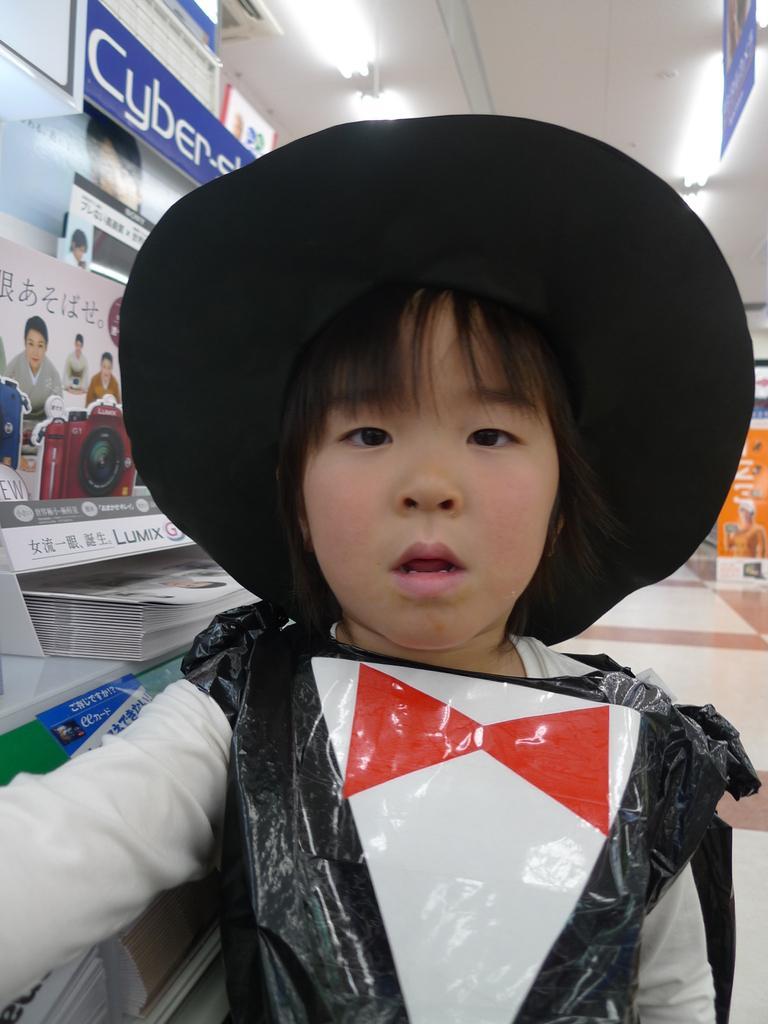In one or two sentences, can you explain what this image depicts? In this image we can see a child wearing a hat. On the ceiling there are lights. On the left side we can see banners. On that there is a camera, images of people and also something is written. And there is a rack with papers. 